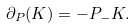<formula> <loc_0><loc_0><loc_500><loc_500>\partial _ { P } ( K ) = - P _ { - } K .</formula> 